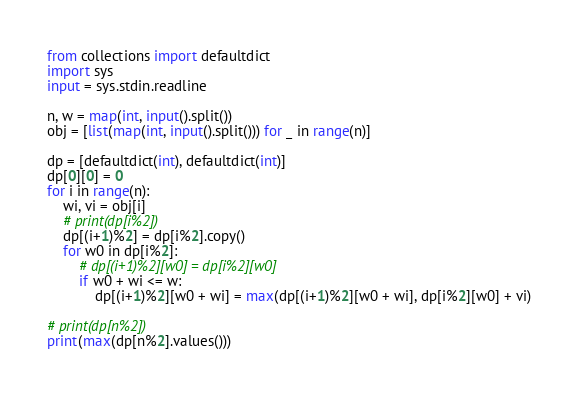Convert code to text. <code><loc_0><loc_0><loc_500><loc_500><_Python_>from collections import defaultdict
import sys
input = sys.stdin.readline

n, w = map(int, input().split())
obj = [list(map(int, input().split())) for _ in range(n)]

dp = [defaultdict(int), defaultdict(int)]
dp[0][0] = 0
for i in range(n):
    wi, vi = obj[i]
    # print(dp[i%2])
    dp[(i+1)%2] = dp[i%2].copy()
    for w0 in dp[i%2]:
        # dp[(i+1)%2][w0] = dp[i%2][w0]
        if w0 + wi <= w:
            dp[(i+1)%2][w0 + wi] = max(dp[(i+1)%2][w0 + wi], dp[i%2][w0] + vi)

# print(dp[n%2])
print(max(dp[n%2].values()))
</code> 